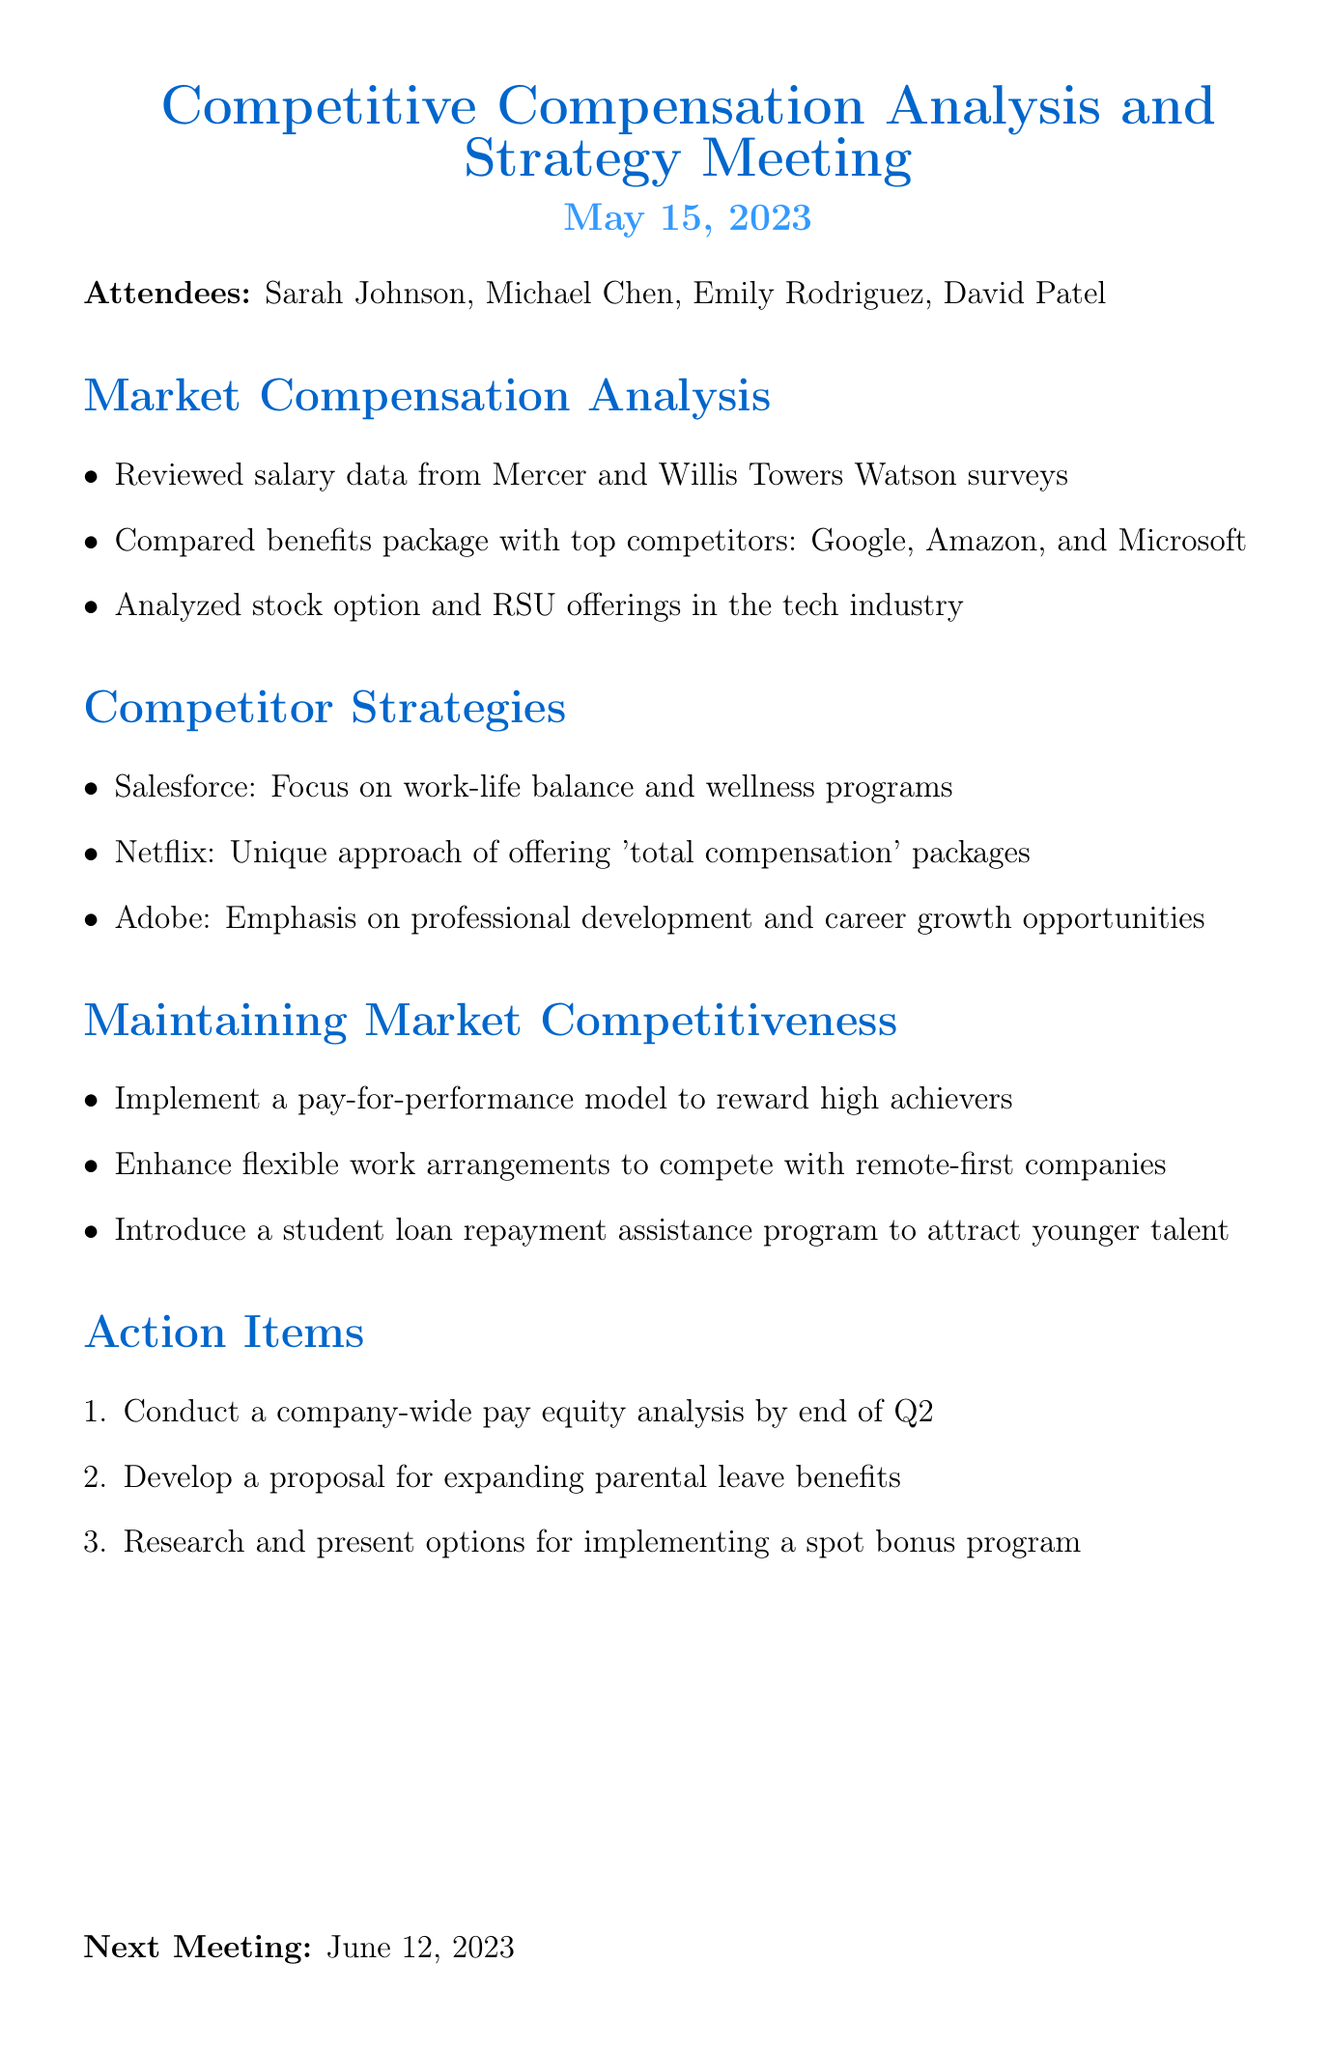What is the date of the meeting? The date of the meeting is specified in the document as May 15, 2023.
Answer: May 15, 2023 Who attended the meeting as the HR Director? The HR Director's name is listed among the attendees in the document, which is Michael Chen.
Answer: Michael Chen Which company has a focus on work-life balance and wellness programs? Salesforce is mentioned in the document as having a focus on work-life balance and wellness programs.
Answer: Salesforce What is one action item mentioned for the next steps? An action item is specified as conducting a company-wide pay equity analysis by the end of Q2.
Answer: Conduct a company-wide pay equity analysis by end of Q2 Which competitors were compared in the benefits package analysis? The document lists the competitors compared in the benefits package analysis as Google, Amazon, and Microsoft.
Answer: Google, Amazon, Microsoft How many attendees were present at the meeting? The number of attendees can be counted from the list provided in the document, which includes four names.
Answer: 4 What compensation model is suggested to reward high achievers? The document suggests implementing a pay-for-performance model to reward high achievers.
Answer: Pay-for-performance model What is the next meeting date scheduled? The next meeting date is stated in the document as June 12, 2023.
Answer: June 12, 2023 What unique approach does Netflix offer in compensation? The unique approach of Netflix in compensation is noted as offering 'total compensation' packages in the document.
Answer: Total compensation packages 